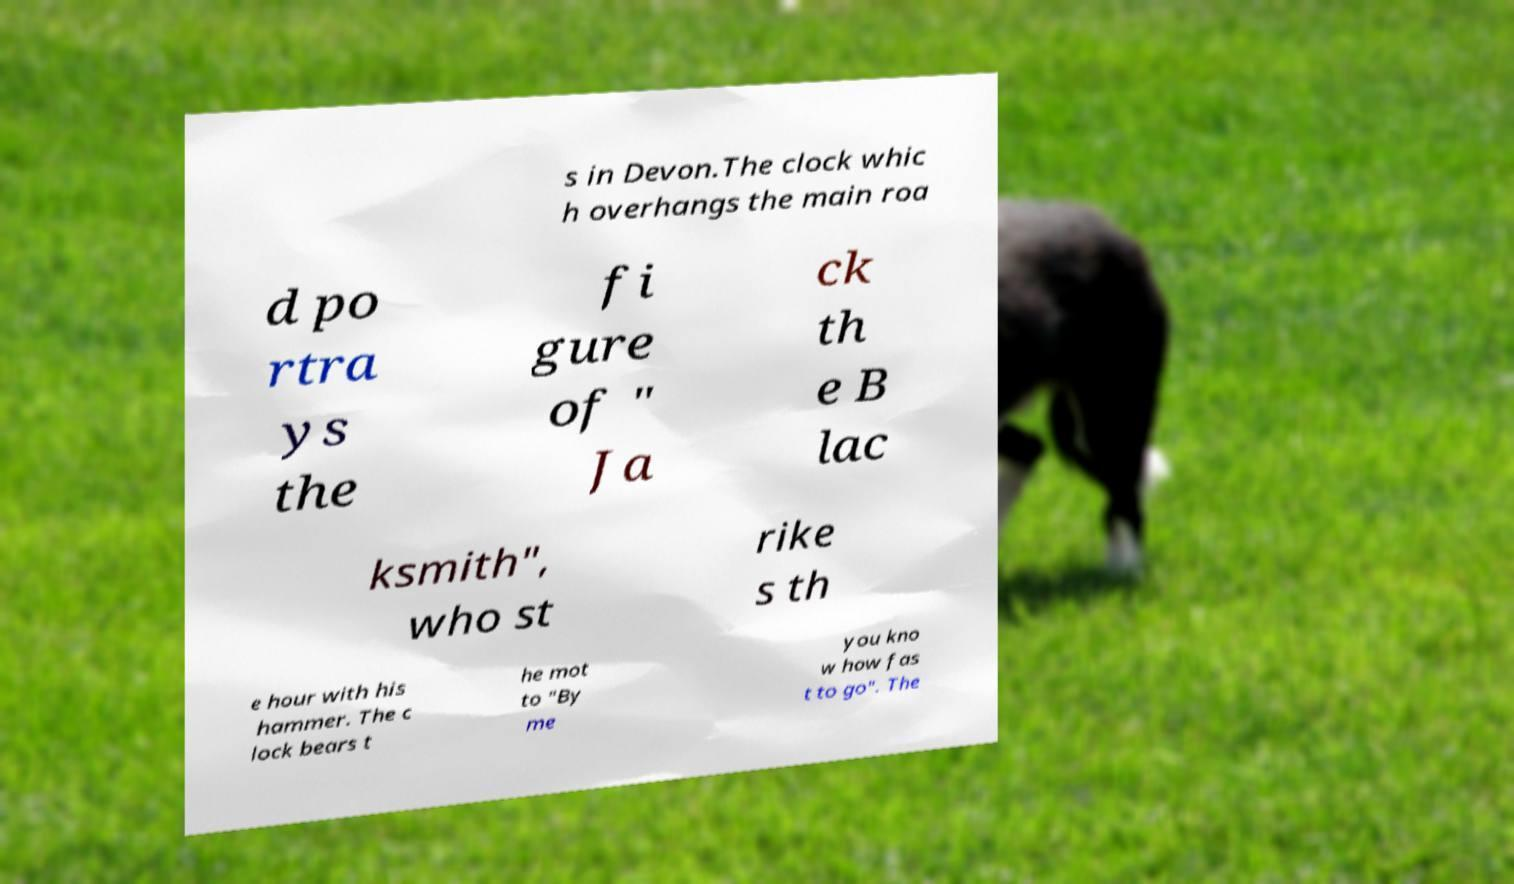Can you accurately transcribe the text from the provided image for me? s in Devon.The clock whic h overhangs the main roa d po rtra ys the fi gure of " Ja ck th e B lac ksmith", who st rike s th e hour with his hammer. The c lock bears t he mot to "By me you kno w how fas t to go". The 